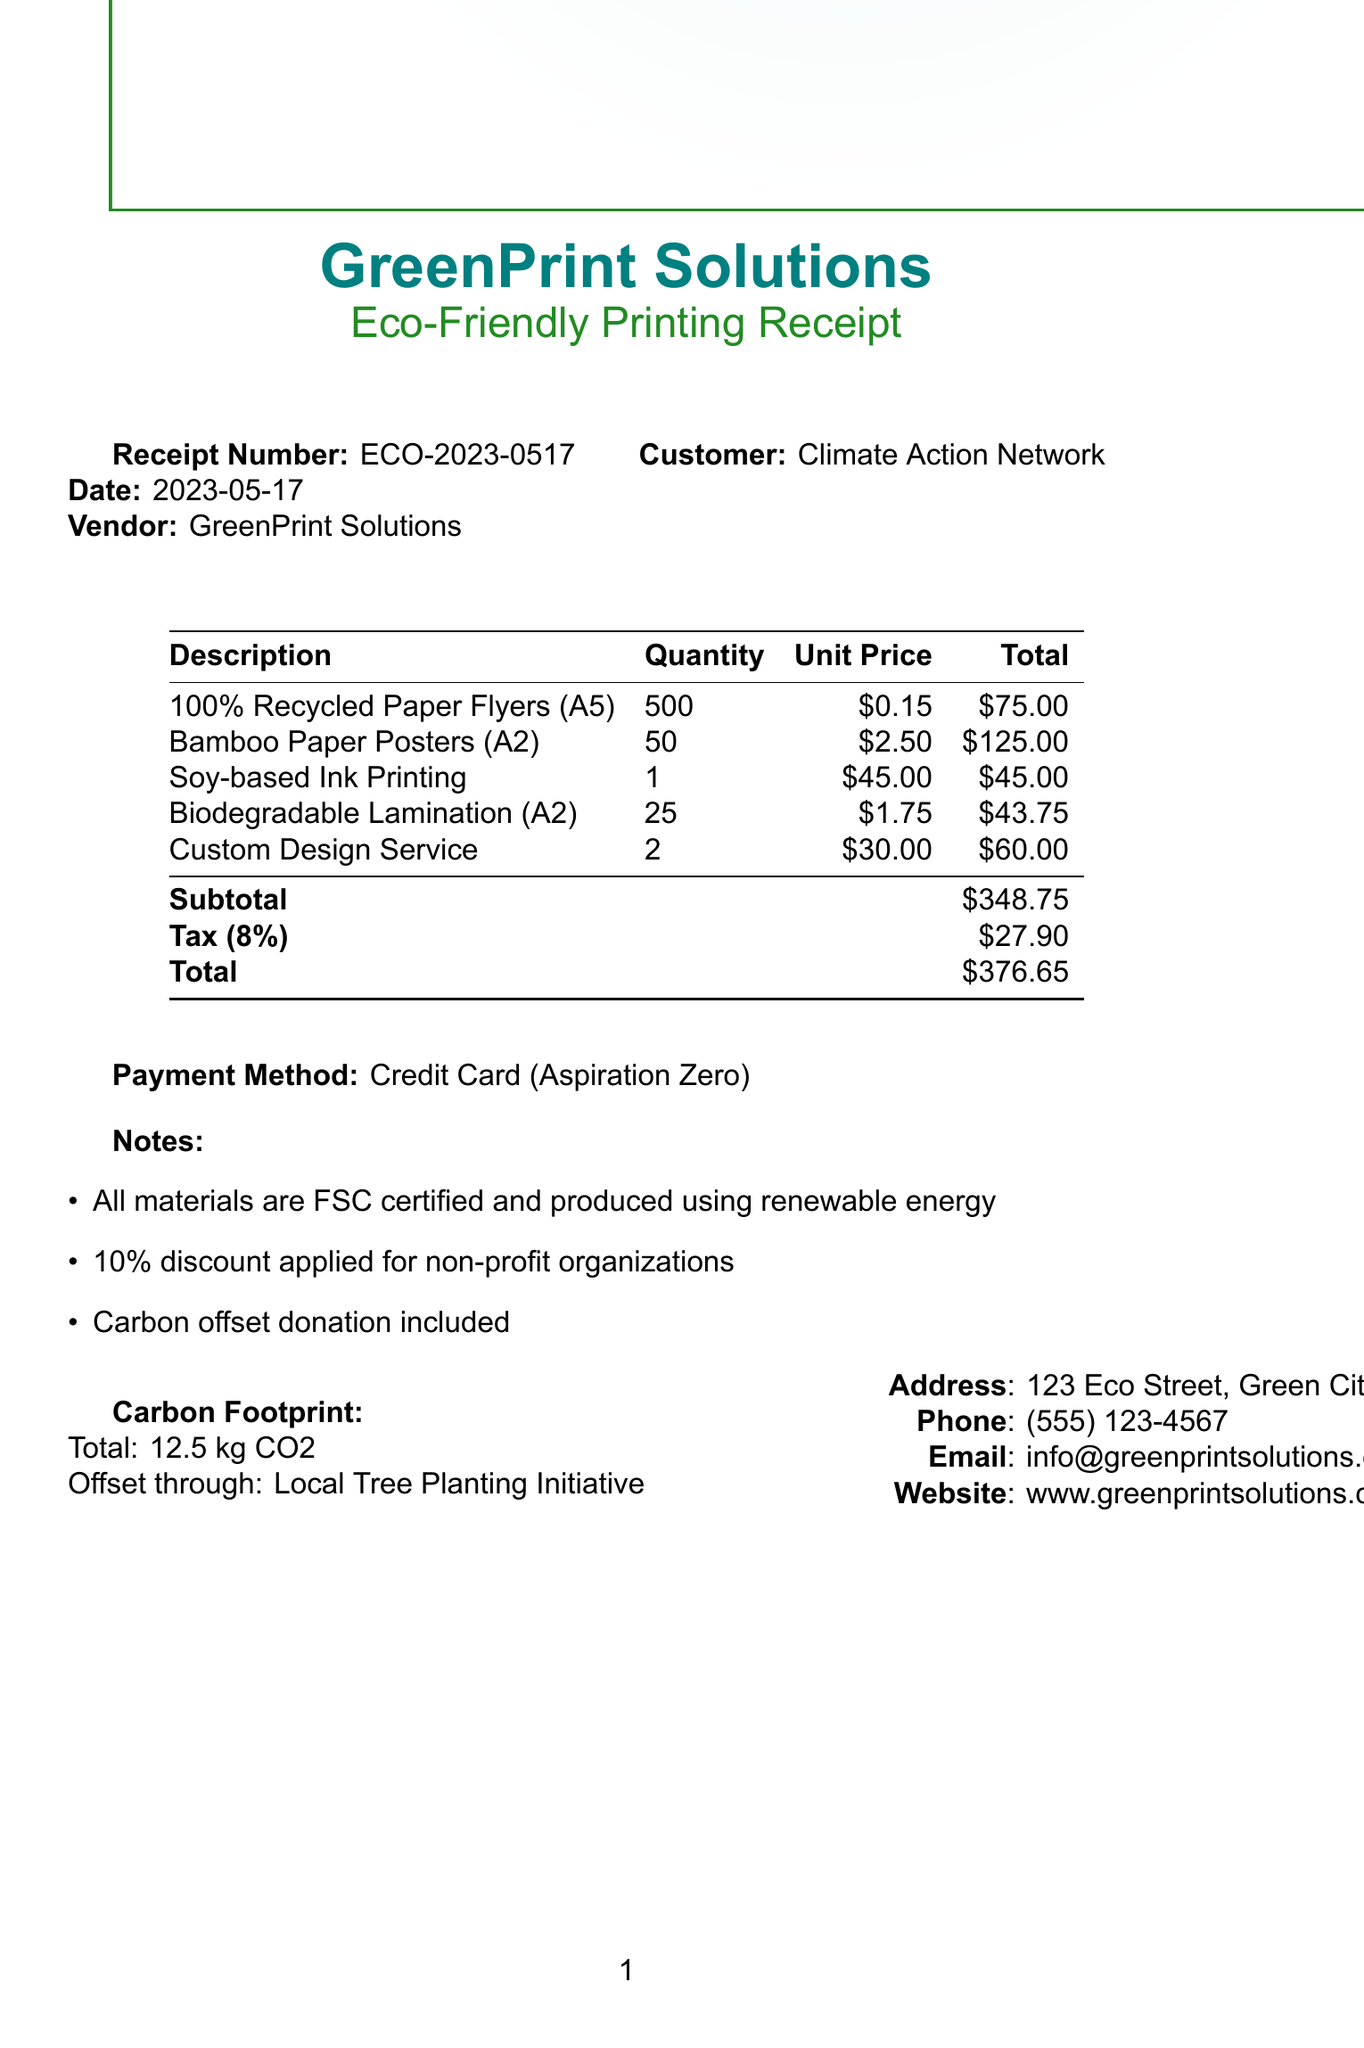What is the receipt number? The receipt number is a unique identifier for the transaction, which is ECO-2023-0517.
Answer: ECO-2023-0517 Who is the vendor? The vendor is the company that provided the printing services, identified as GreenPrint Solutions.
Answer: GreenPrint Solutions What is the total amount? The total amount is the overall cost that includes subtotals and taxes, which sums up to $376.65.
Answer: $376.65 How many flyers were printed? The document lists the quantity of printed flyers, which is 500.
Answer: 500 What type of printing ink was used? The type of ink used for the printing is specified in the document as soy-based ink.
Answer: Soy-based Ink What is the tax rate on the receipt? The tax rate applied to the receipt is provided as 8%.
Answer: 8% What discount was applied? A discount is mentioned that was applied specifically for non-profit organizations, which is 10%.
Answer: 10% What is the subtotal before tax? The subtotal before tax is documented as $348.75.
Answer: $348.75 What eco-friendly initiative was mentioned? The document mentions a local tree planting initiative which was used for carbon offset.
Answer: Local Tree Planting Initiative 